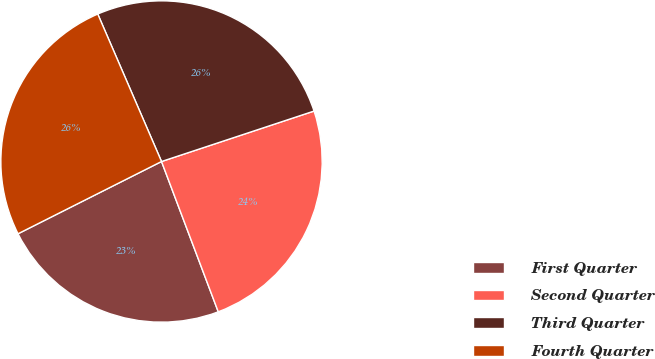Convert chart. <chart><loc_0><loc_0><loc_500><loc_500><pie_chart><fcel>First Quarter<fcel>Second Quarter<fcel>Third Quarter<fcel>Fourth Quarter<nl><fcel>23.32%<fcel>24.34%<fcel>26.41%<fcel>25.93%<nl></chart> 